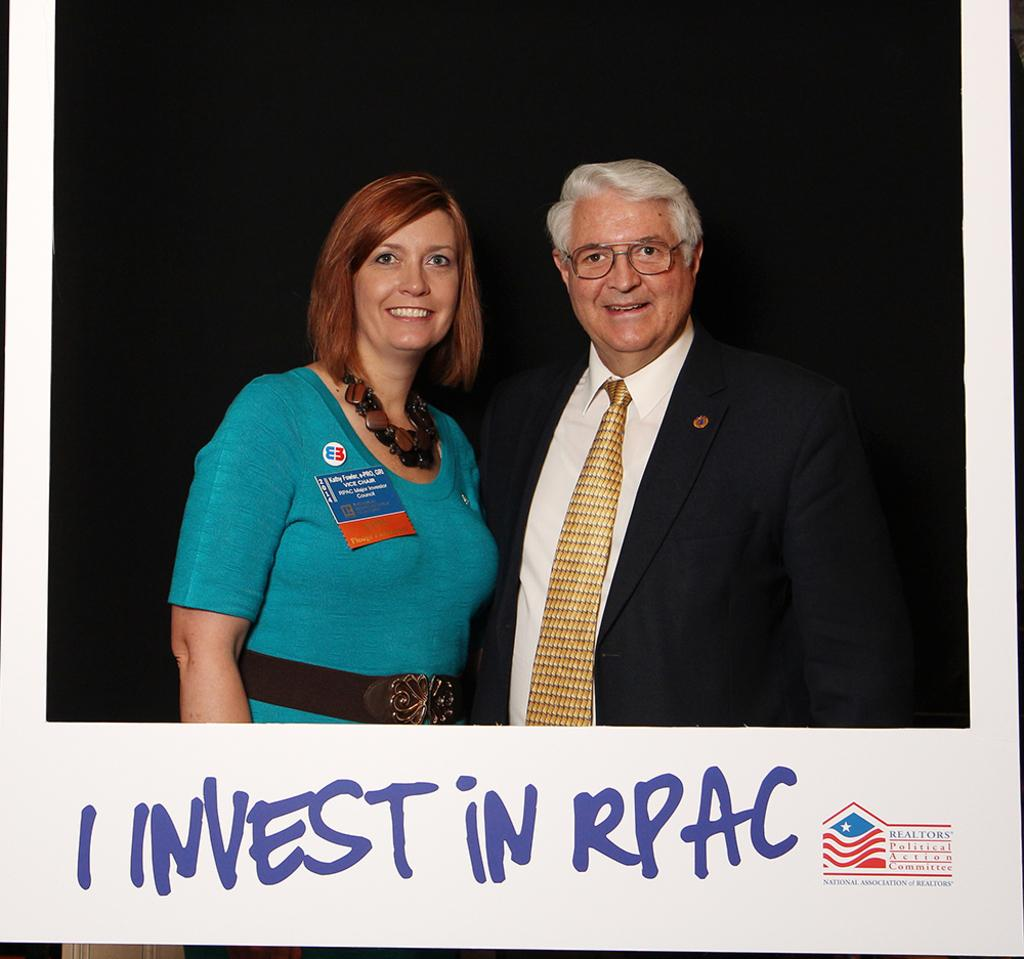<image>
Summarize the visual content of the image. A photo of a man and woman with I invest in RPAC written under it. 